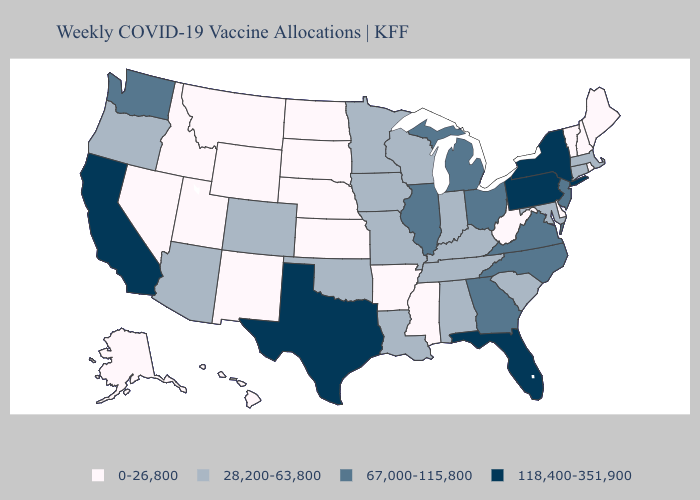Name the states that have a value in the range 67,000-115,800?
Short answer required. Georgia, Illinois, Michigan, New Jersey, North Carolina, Ohio, Virginia, Washington. Does Washington have the highest value in the USA?
Answer briefly. No. What is the value of Colorado?
Keep it brief. 28,200-63,800. Which states have the highest value in the USA?
Answer briefly. California, Florida, New York, Pennsylvania, Texas. What is the value of California?
Be succinct. 118,400-351,900. What is the highest value in states that border Colorado?
Write a very short answer. 28,200-63,800. Does Nebraska have the lowest value in the USA?
Write a very short answer. Yes. What is the value of Connecticut?
Give a very brief answer. 28,200-63,800. Does California have the highest value in the USA?
Be succinct. Yes. Which states hav the highest value in the MidWest?
Give a very brief answer. Illinois, Michigan, Ohio. Among the states that border Maryland , which have the lowest value?
Quick response, please. Delaware, West Virginia. Does the first symbol in the legend represent the smallest category?
Be succinct. Yes. What is the lowest value in states that border Kansas?
Concise answer only. 0-26,800. What is the value of Delaware?
Concise answer only. 0-26,800. What is the value of Oklahoma?
Answer briefly. 28,200-63,800. 